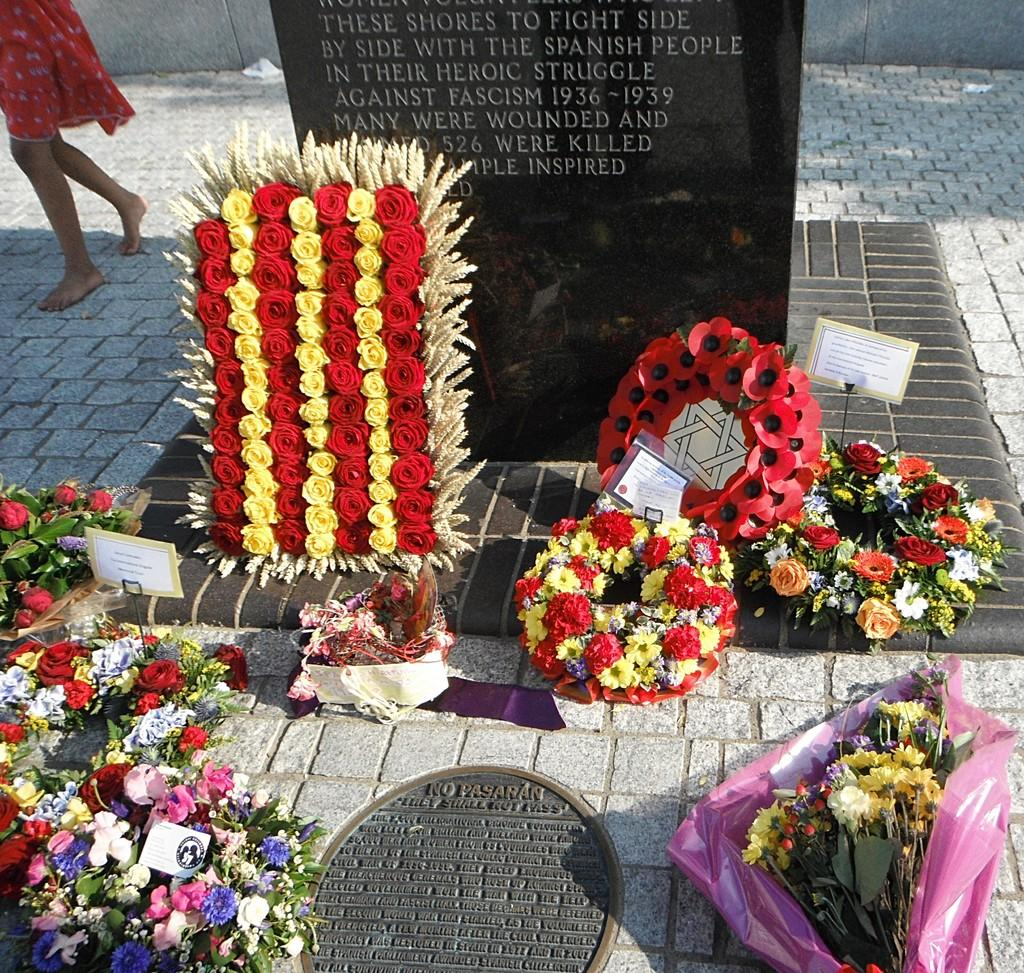What can be seen on the ground in the foreground of the image? There are bouquets on the ground in the foreground of the image. What is visible on a stone in the background of the image? There is text on a stone in the background of the image. What is the girl in the background of the image doing? A girl is walking on the ground in the background of the image. What type of company is present in the image? There is no company present in the image; it features bouquets, text on a stone, and a girl walking. What unit of measurement is used to describe the size of the bouquets in the image? The size of the bouquets in the image is not described in terms of a specific unit of measurement. 